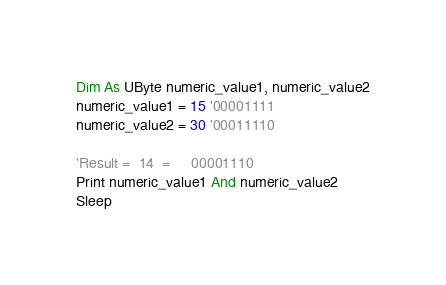<code> <loc_0><loc_0><loc_500><loc_500><_VisualBasic_>Dim As UByte numeric_value1, numeric_value2
numeric_value1 = 15 '00001111
numeric_value2 = 30 '00011110

'Result =  14  =     00001110
Print numeric_value1 And numeric_value2
Sleep
</code> 